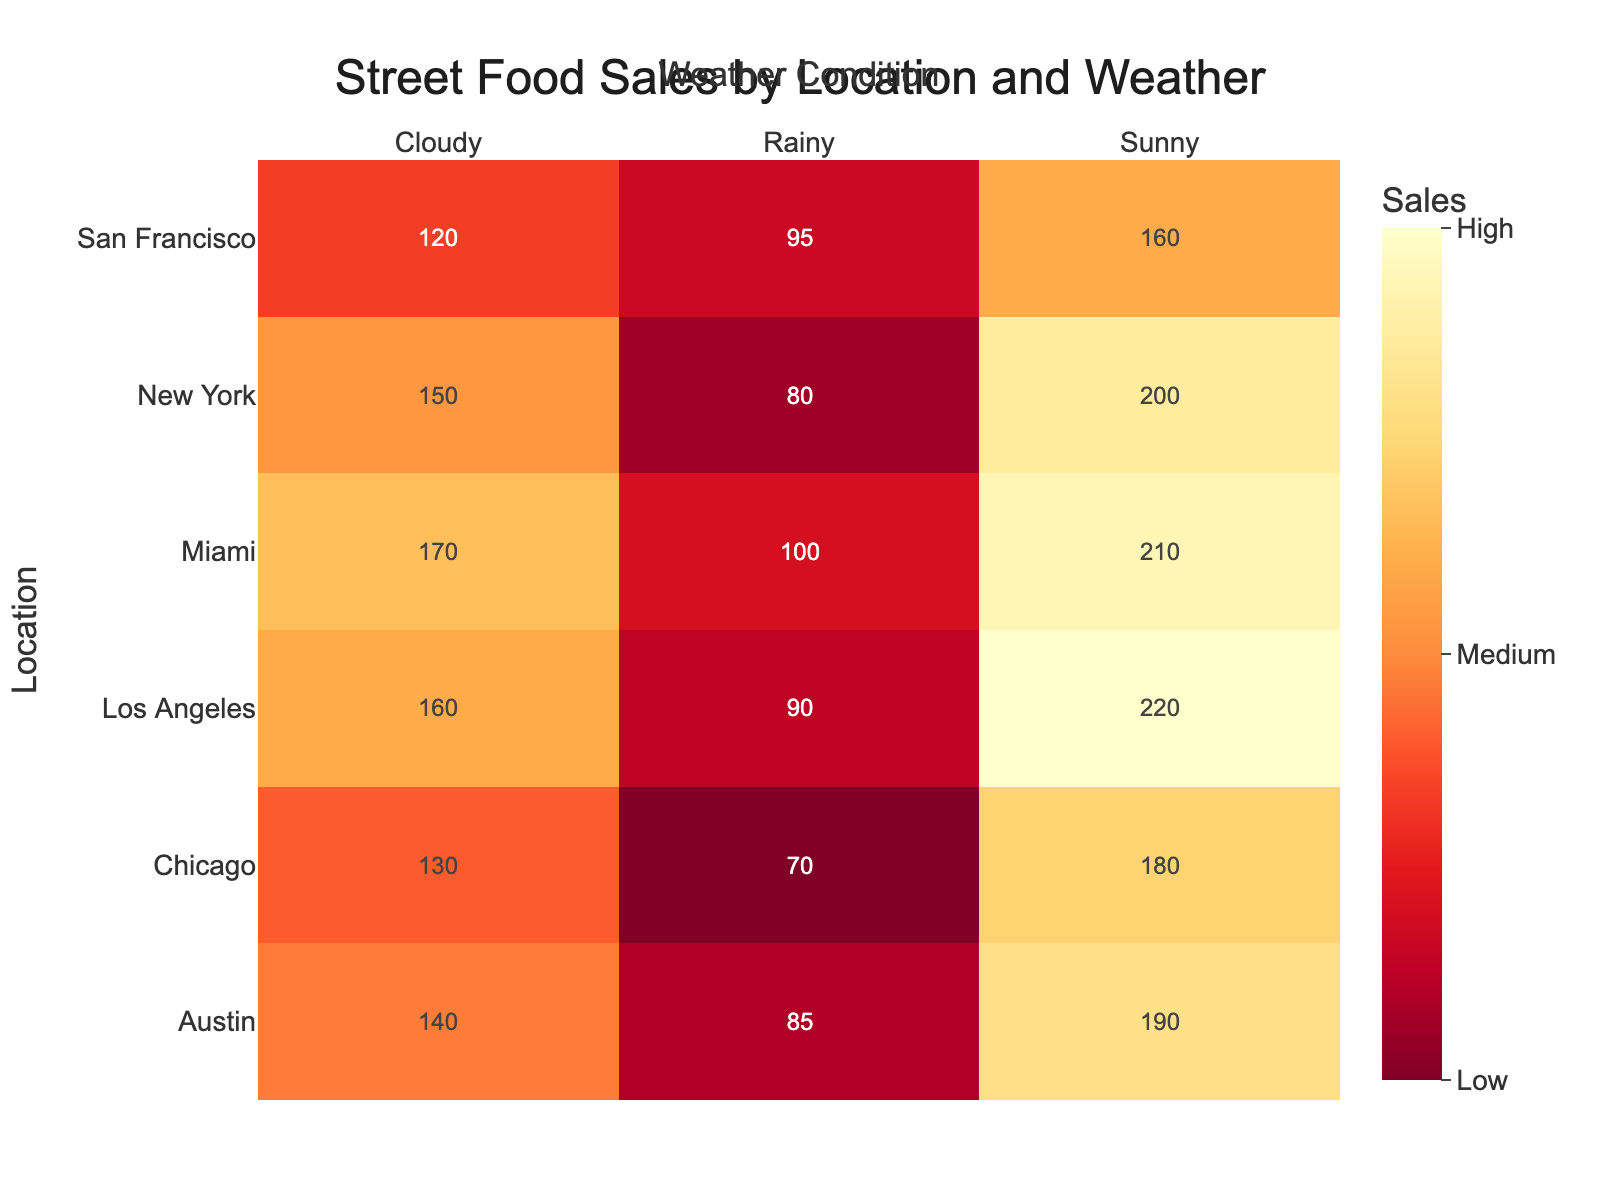Which location has the highest sales on sunny days? Look at the cells corresponding to "Sunny" for each location and identify the highest number.
Answer: Los Angeles How much higher are New York's sales on sunny days compared to rainy days? Locate the sales figures for New York under "Sunny" and "Rainy". Subtract the rainy day sales from the sunny day sales (200 - 80).
Answer: 120 Which weather condition generally results in the lowest sales for most locations? Compare the sales figures across different weather conditions (Sunny, Rainy, Cloudy) for all locations. Identify the condition with frequently lower sales.
Answer: Rainy What is the total sales in Miami across all weather conditions? Sum the sales figures for Miami under "Sunny," "Rainy," and "Cloudy" (210 + 100 + 170).
Answer: 480 How does Chicago's sales on cloudy days compare to those on sunny days? Locate the sales figures for Chicago under "Cloudy" and "Sunny." Compare these two figures (130 vs. 180).
Answer: Lower What is the overall trend in sales as the weather condition changes from sunny to rainy to cloudy? Examine and summarize the trend in sales figures from Sunny to Rainy to Cloudy for all locations.
Answer: Decrease Identify the city with the lowest sales on a cloudy day. Look for the smallest number under the "Cloudy" column for all cities.
Answer: San Francisco How much is the sales difference between Los Angeles and Austin on sunny days? Locate the sales figures for Los Angeles and Austin under "Sunny." Subtract the smaller number from the larger (220 - 190).
Answer: 30 On which weather condition does New York perform the second-best in terms of sales? Identify the sales numbers for New York under each weather condition and rank them.
Answer: Cloudy Which city has the smallest variation in sales across different weather conditions? Calculate the range (difference between highest and lowest) of sales for each city and identify the smallest one.
Answer: San Francisco 